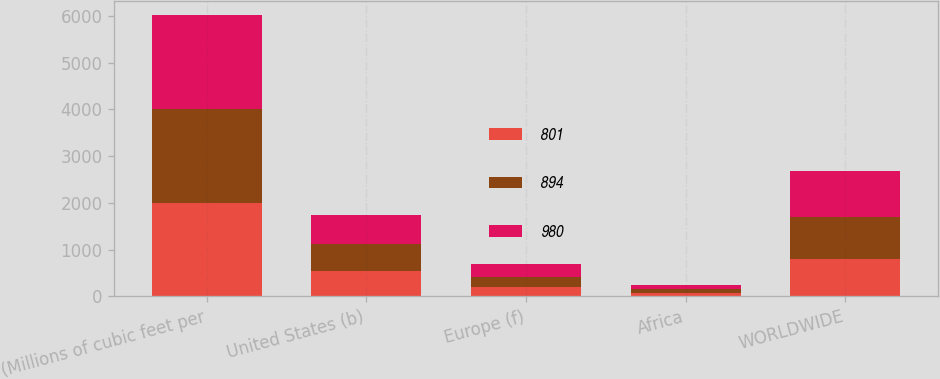<chart> <loc_0><loc_0><loc_500><loc_500><stacked_bar_chart><ecel><fcel>(Millions of cubic feet per<fcel>United States (b)<fcel>Europe (f)<fcel>Africa<fcel>WORLDWIDE<nl><fcel>801<fcel>2006<fcel>532<fcel>197<fcel>72<fcel>801<nl><fcel>894<fcel>2005<fcel>578<fcel>224<fcel>92<fcel>894<nl><fcel>980<fcel>2004<fcel>631<fcel>273<fcel>76<fcel>980<nl></chart> 